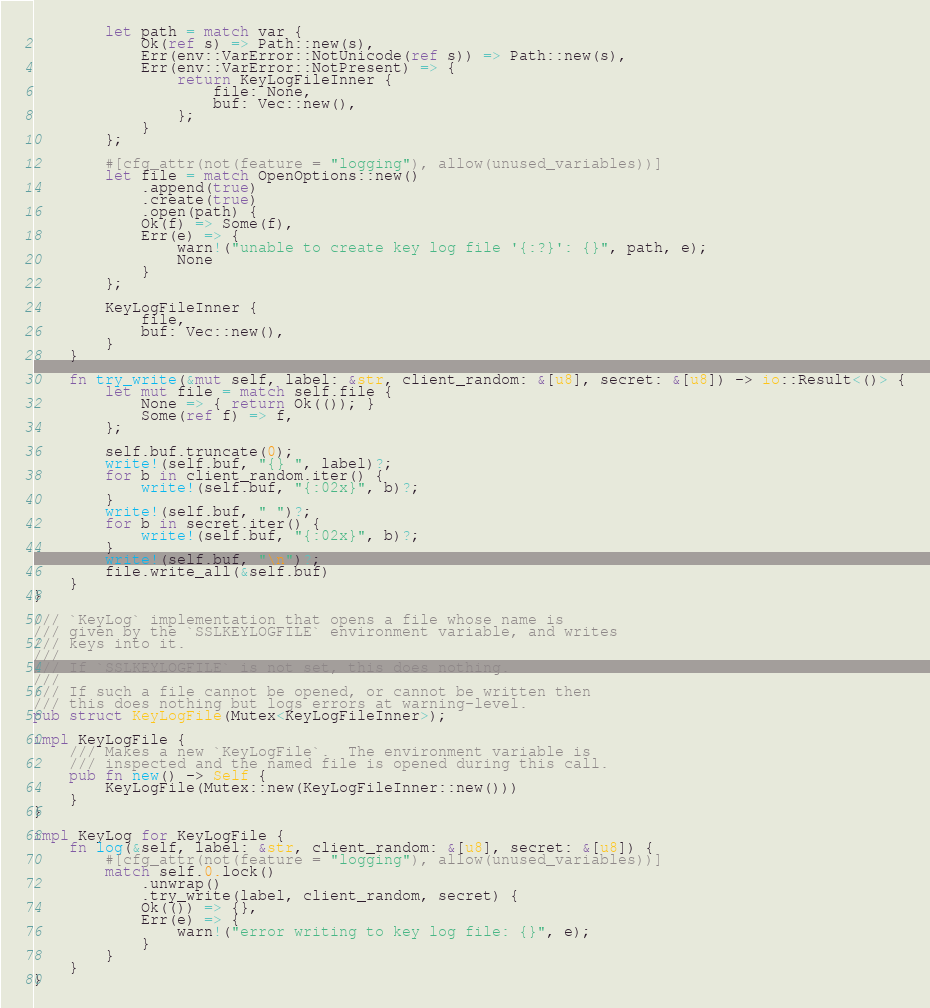Convert code to text. <code><loc_0><loc_0><loc_500><loc_500><_Rust_>        let path = match var {
            Ok(ref s) => Path::new(s),
            Err(env::VarError::NotUnicode(ref s)) => Path::new(s),
            Err(env::VarError::NotPresent) => {
                return KeyLogFileInner {
                    file: None,
                    buf: Vec::new(),
                };
            }
        };

        #[cfg_attr(not(feature = "logging"), allow(unused_variables))]
        let file = match OpenOptions::new()
            .append(true)
            .create(true)
            .open(path) {
            Ok(f) => Some(f),
            Err(e) => {
                warn!("unable to create key log file '{:?}': {}", path, e);
                None
            }
        };

        KeyLogFileInner {
            file,
            buf: Vec::new(),
        }
    }

    fn try_write(&mut self, label: &str, client_random: &[u8], secret: &[u8]) -> io::Result<()> {
        let mut file = match self.file {
            None => { return Ok(()); }
            Some(ref f) => f,
        };

        self.buf.truncate(0);
        write!(self.buf, "{} ", label)?;
        for b in client_random.iter() {
            write!(self.buf, "{:02x}", b)?;
        }
        write!(self.buf, " ")?;
        for b in secret.iter() {
            write!(self.buf, "{:02x}", b)?;
        }
        write!(self.buf, "\n")?;
        file.write_all(&self.buf)
    }
}

/// `KeyLog` implementation that opens a file whose name is
/// given by the `SSLKEYLOGFILE` environment variable, and writes
/// keys into it.
///
/// If `SSLKEYLOGFILE` is not set, this does nothing.
///
/// If such a file cannot be opened, or cannot be written then
/// this does nothing but logs errors at warning-level.
pub struct KeyLogFile(Mutex<KeyLogFileInner>);

impl KeyLogFile {
    /// Makes a new `KeyLogFile`.  The environment variable is
    /// inspected and the named file is opened during this call.
    pub fn new() -> Self {
        KeyLogFile(Mutex::new(KeyLogFileInner::new()))
    }
}

impl KeyLog for KeyLogFile {
    fn log(&self, label: &str, client_random: &[u8], secret: &[u8]) {
        #[cfg_attr(not(feature = "logging"), allow(unused_variables))]
        match self.0.lock()
            .unwrap()
            .try_write(label, client_random, secret) {
            Ok(()) => {},
            Err(e) => {
                warn!("error writing to key log file: {}", e);
            }
        }
    }
}

</code> 